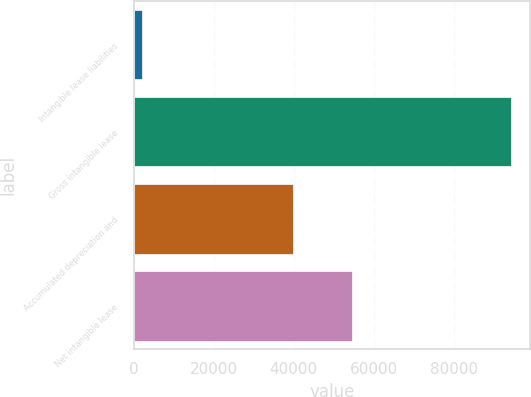<chart> <loc_0><loc_0><loc_500><loc_500><bar_chart><fcel>Intangible lease liabilities<fcel>Gross intangible lease<fcel>Accumulated depreciation and<fcel>Net intangible lease<nl><fcel>2018<fcel>94444<fcel>39781<fcel>54663<nl></chart> 